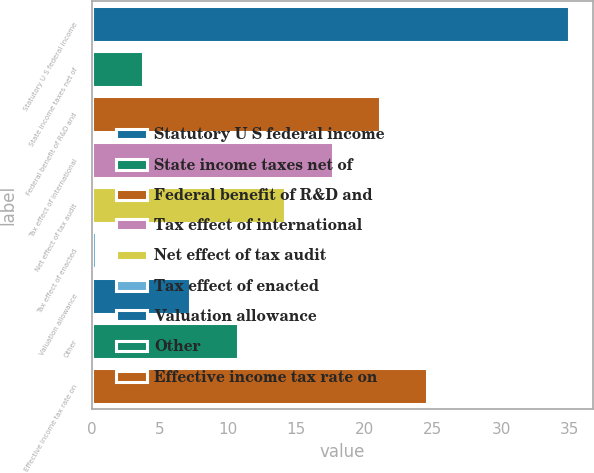<chart> <loc_0><loc_0><loc_500><loc_500><bar_chart><fcel>Statutory U S federal income<fcel>State income taxes net of<fcel>Federal benefit of R&D and<fcel>Tax effect of international<fcel>Net effect of tax audit<fcel>Tax effect of enacted<fcel>Valuation allowance<fcel>Other<fcel>Effective income tax rate on<nl><fcel>35<fcel>3.77<fcel>21.12<fcel>17.65<fcel>14.18<fcel>0.3<fcel>7.24<fcel>10.71<fcel>24.59<nl></chart> 